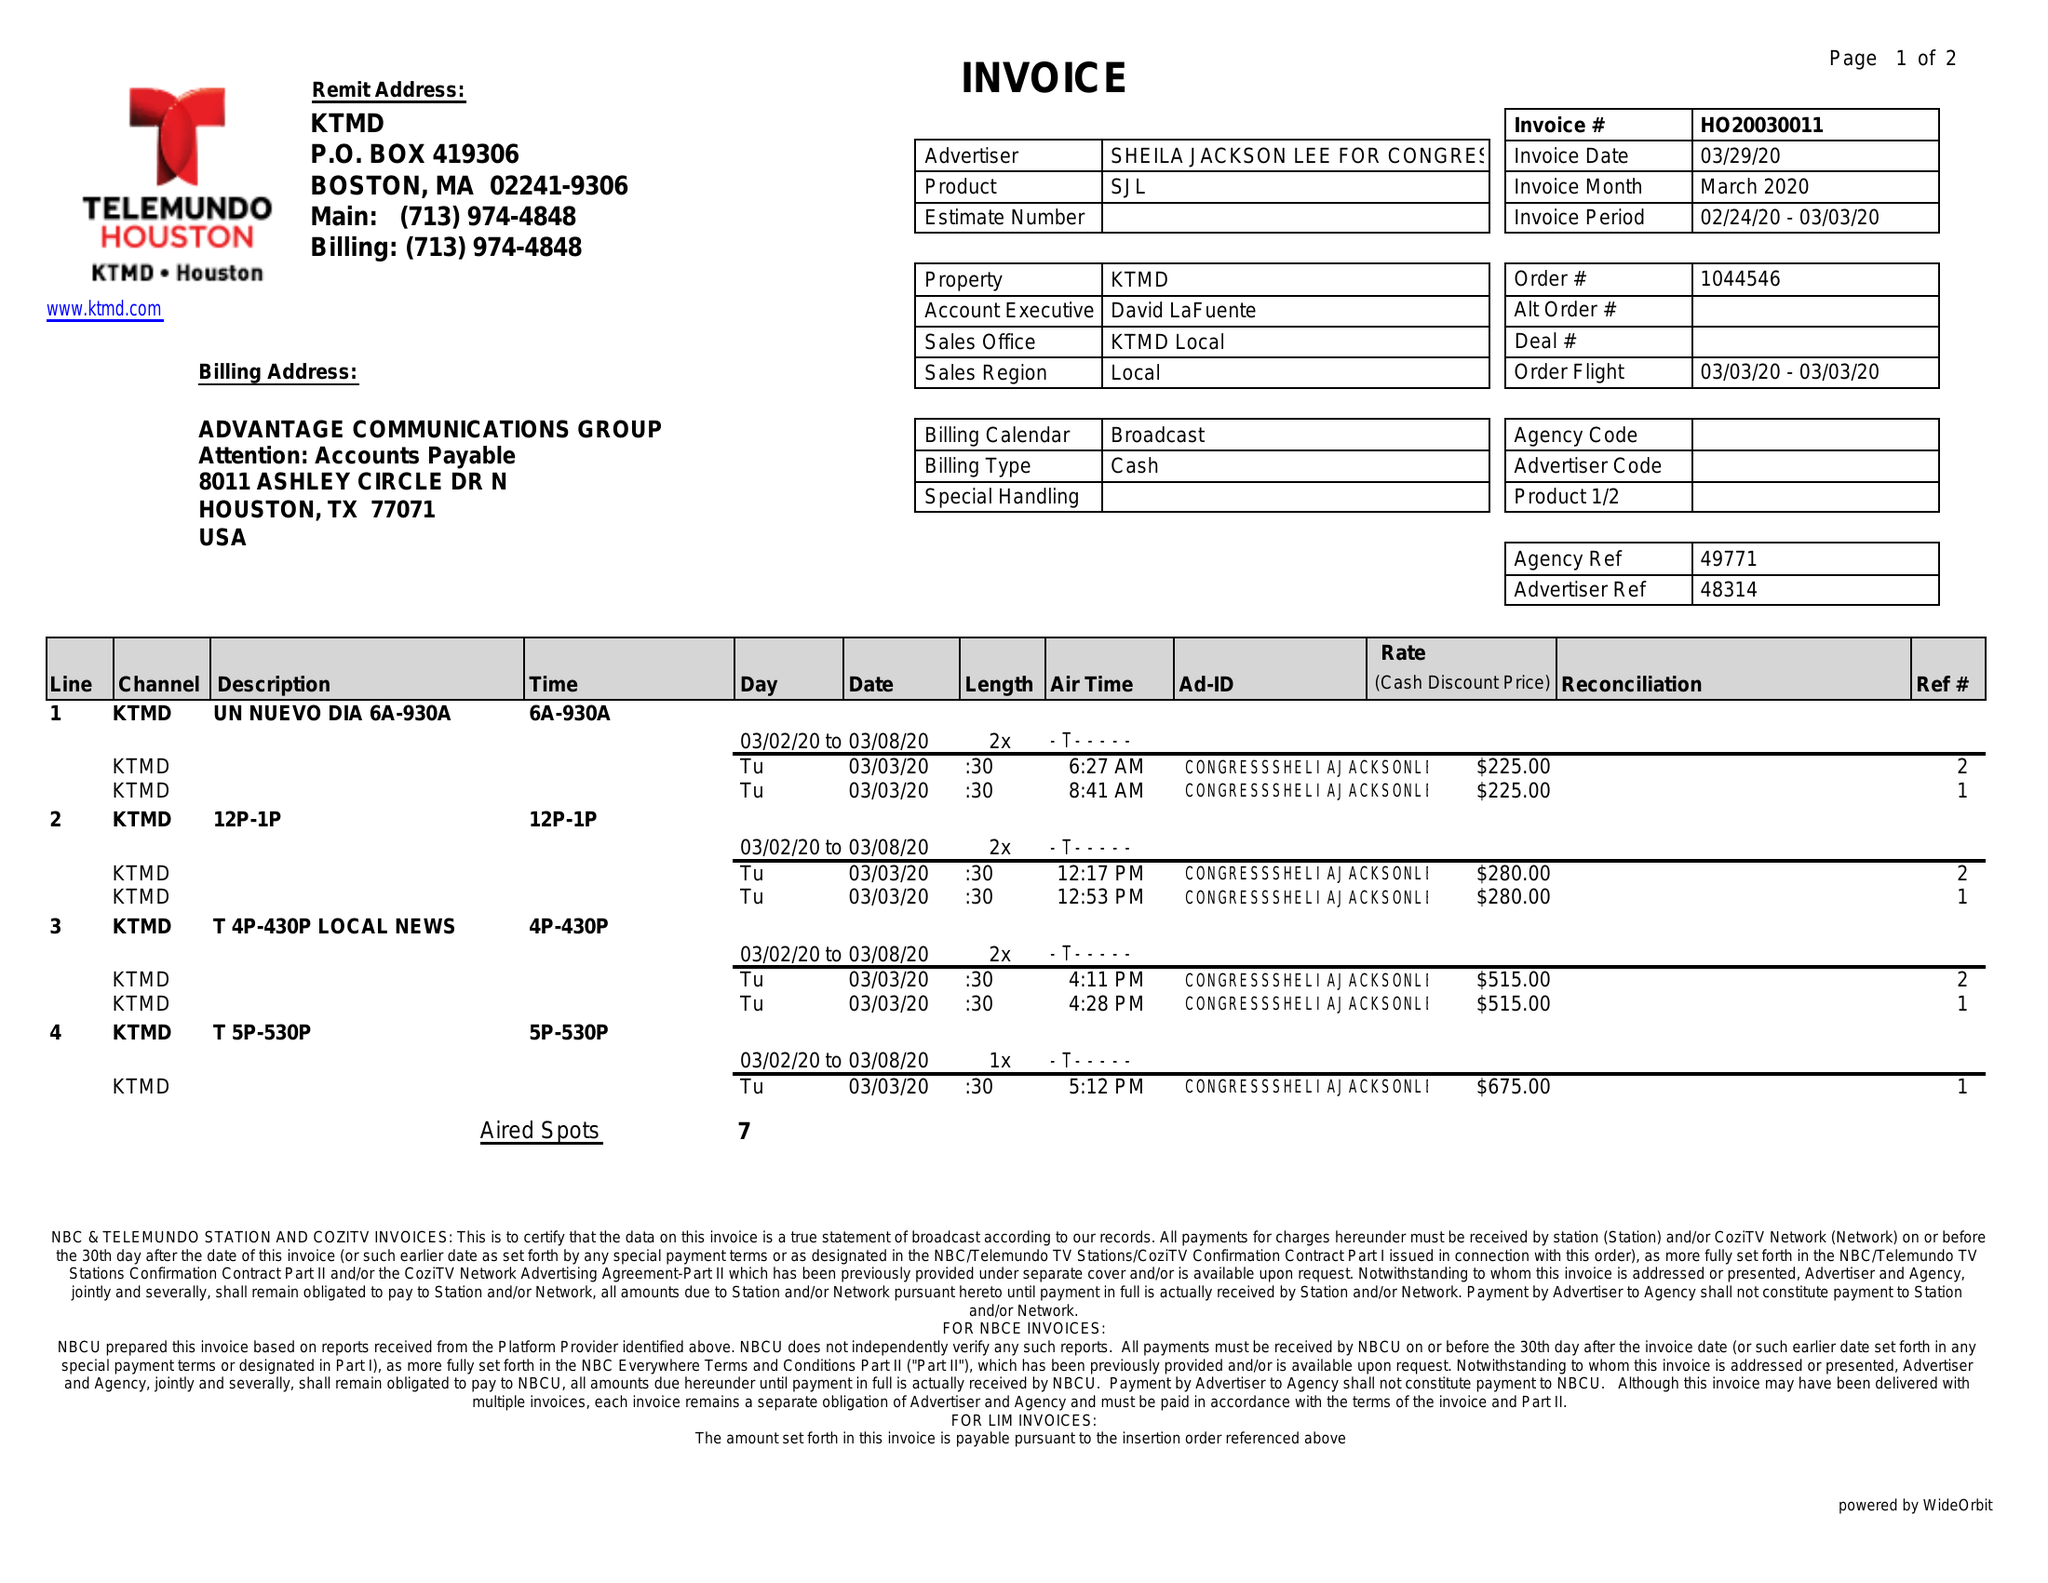What is the value for the contract_num?
Answer the question using a single word or phrase. HO20030011 